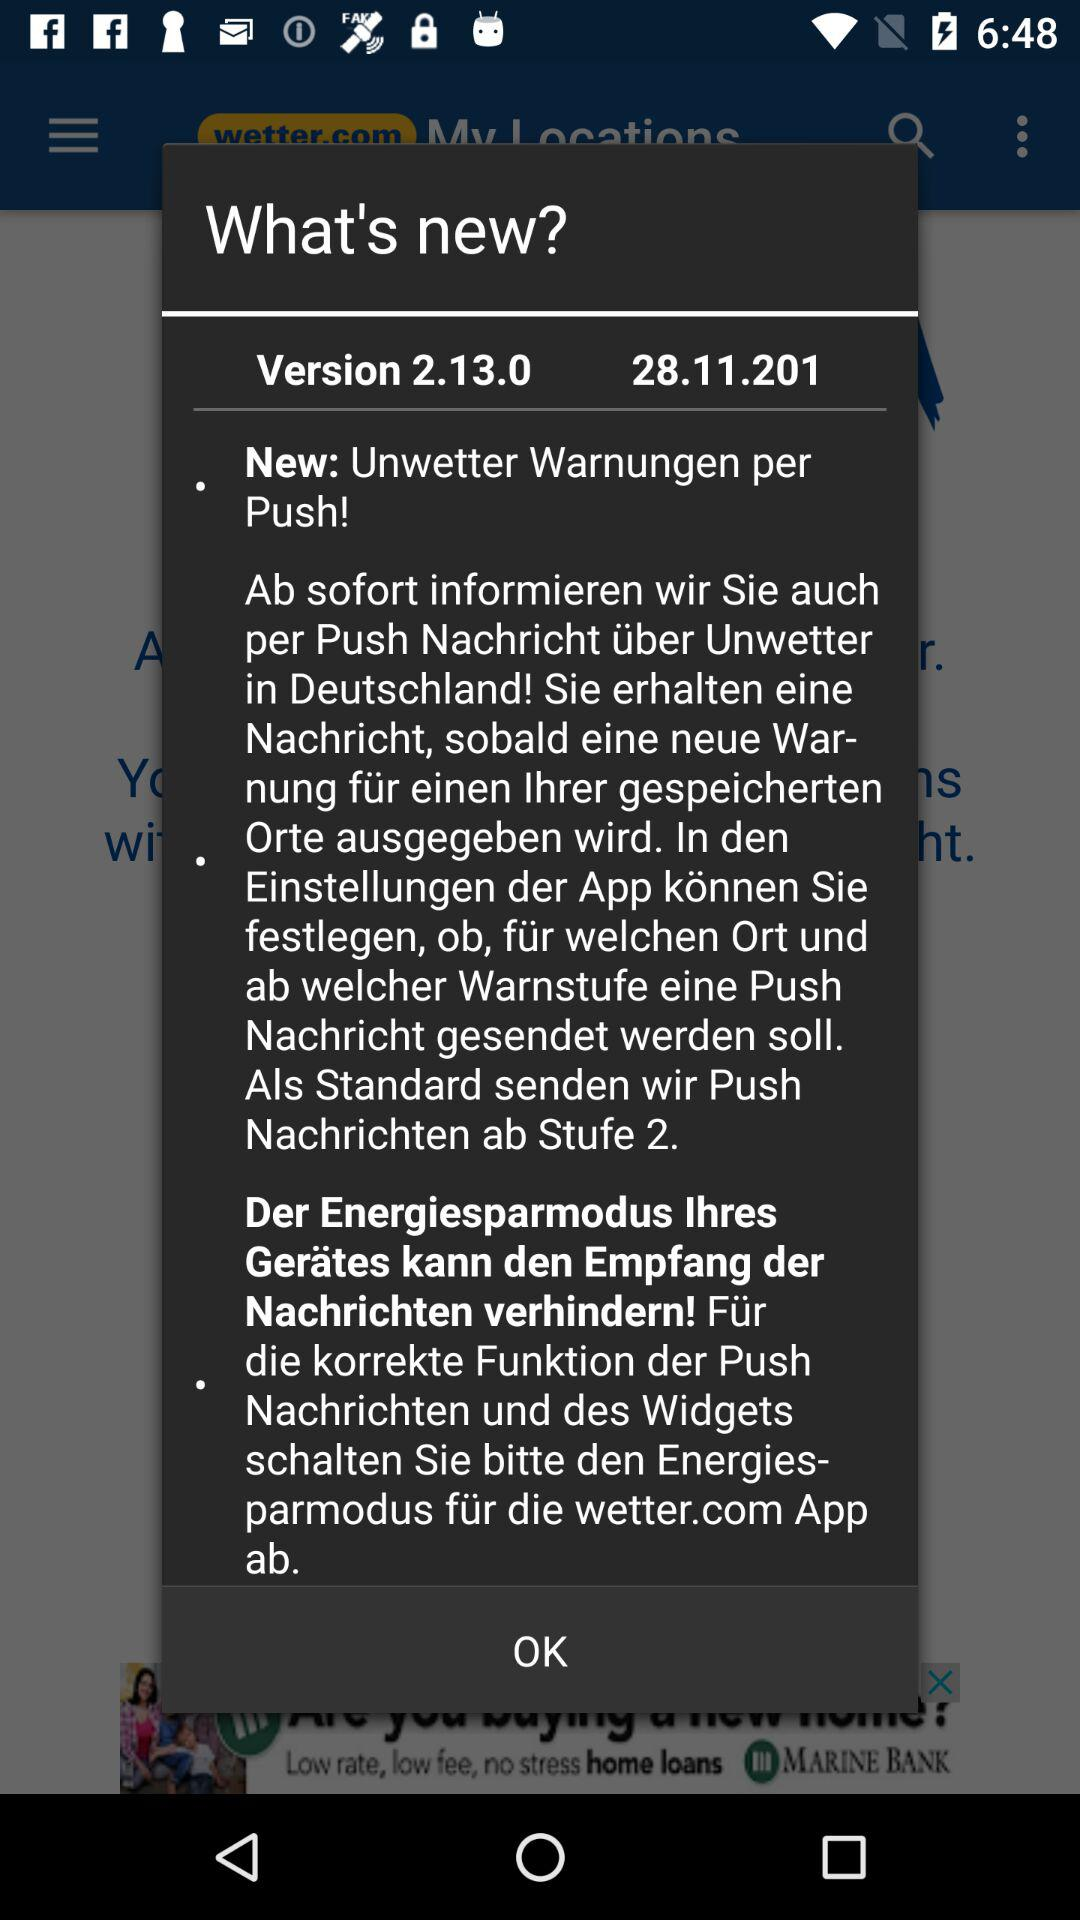What is the version? The version is 2.13.0. 